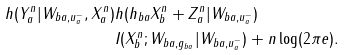<formula> <loc_0><loc_0><loc_500><loc_500>h ( Y _ { a } ^ { n } | W _ { b a , u _ { a } ^ { - } } , X _ { a } ^ { n } ) & h ( h _ { b a } X _ { b } ^ { n } + Z _ { a } ^ { n } | W _ { b a , u _ { a } ^ { - } } ) \\ & I ( X _ { b } ^ { n } ; W _ { b a , g _ { b a } } | W _ { b a , u _ { a } ^ { - } } ) + n \log ( 2 \pi e ) .</formula> 